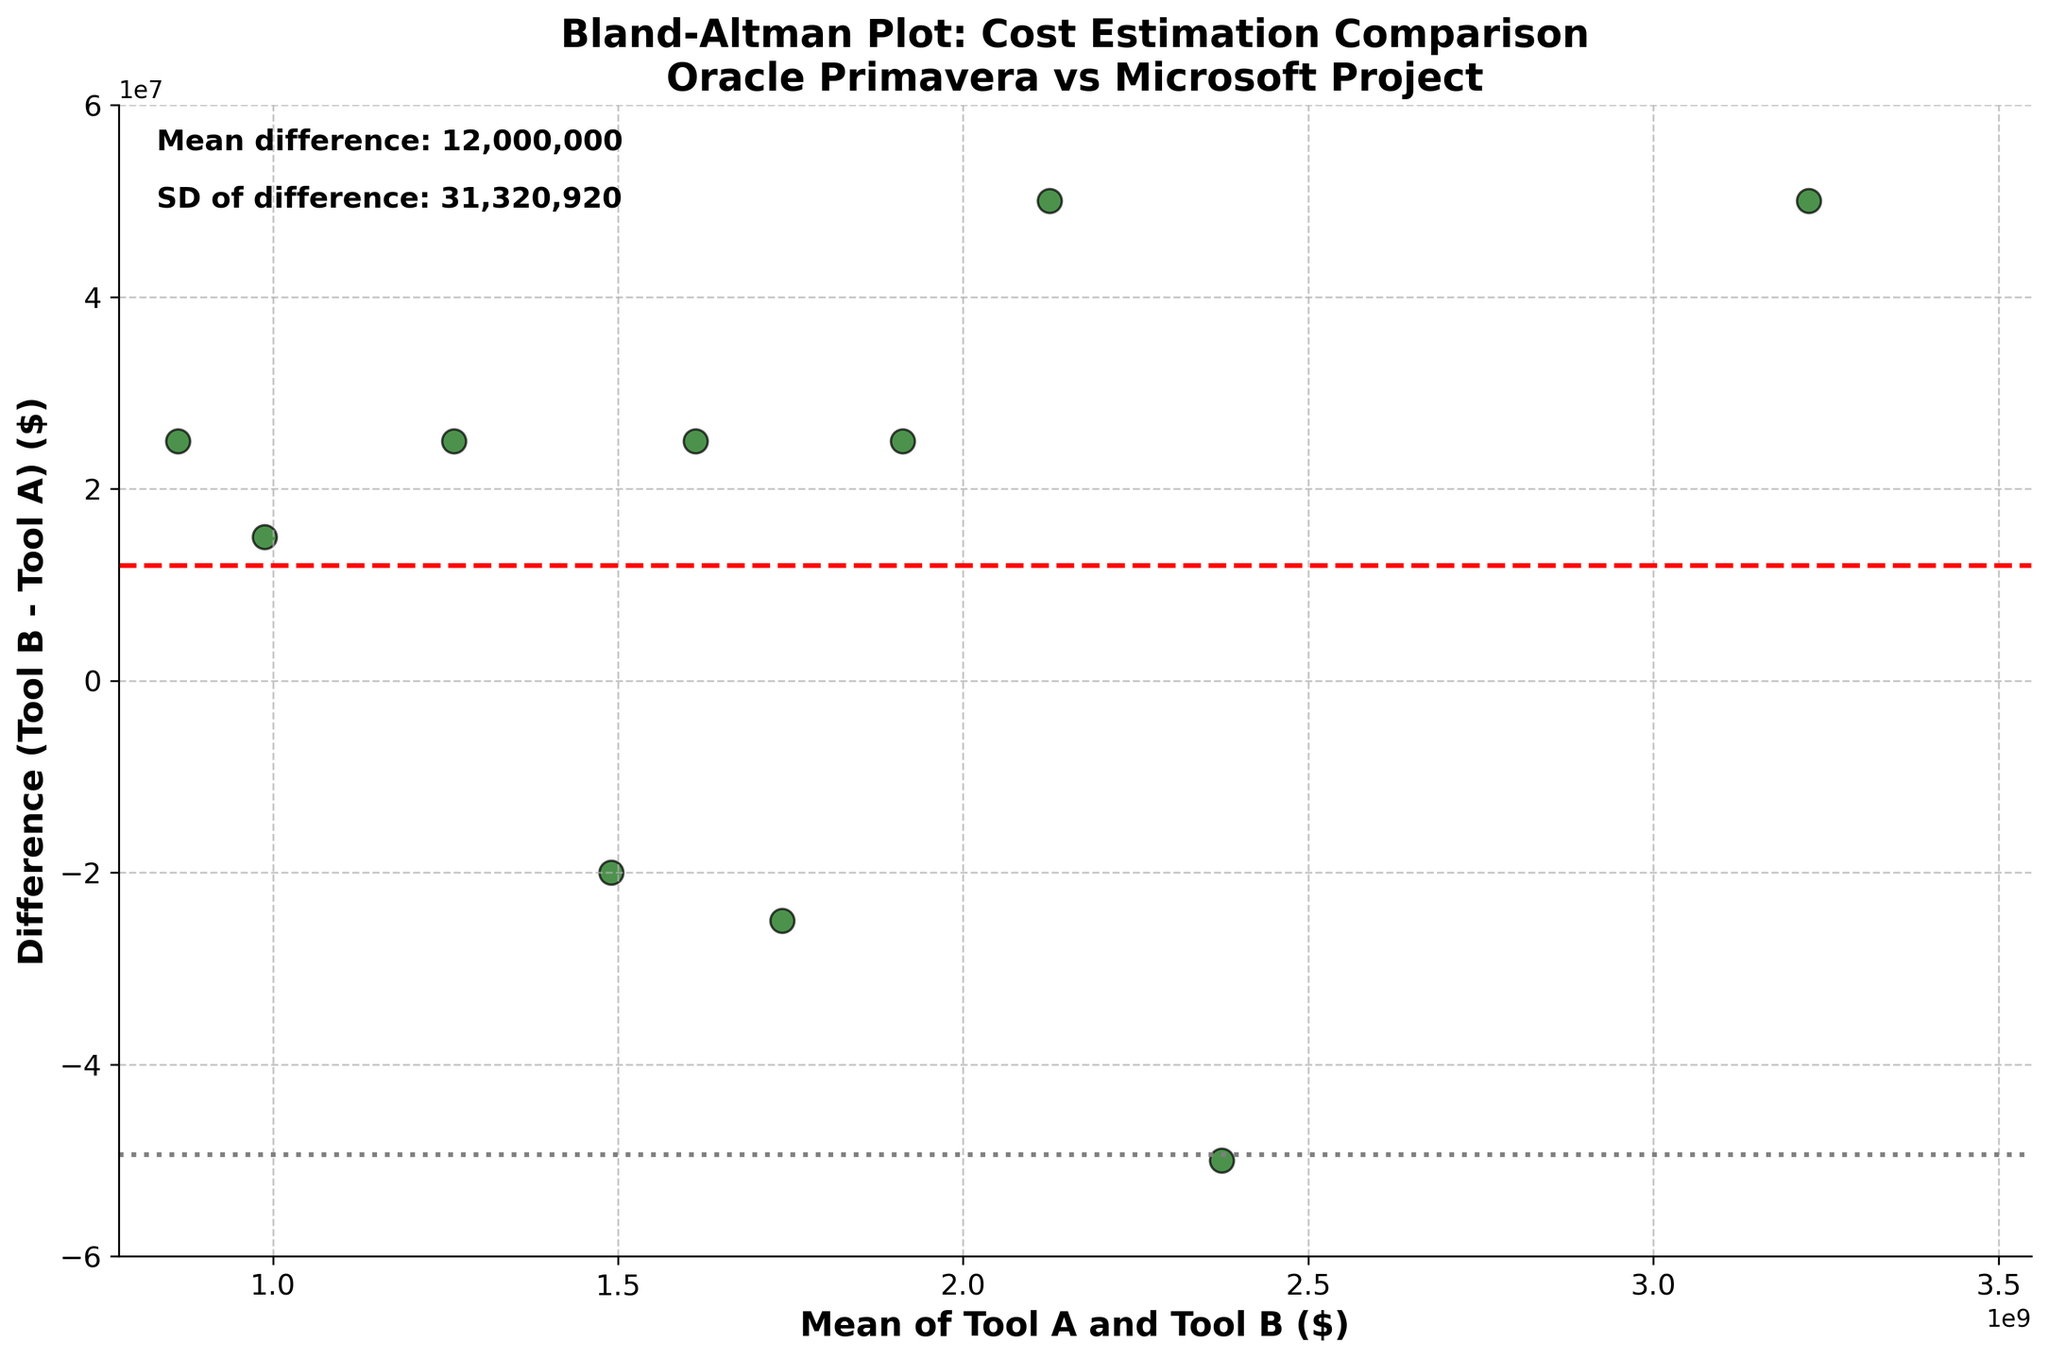What is the title of the figure? The title of the figure is written at the top of the plot.
Answer: Bland-Altman Plot: Cost Estimation Comparison\nOracle Primavera vs Microsoft Project How many data points are represented in the plot? Each data point corresponds to a pair of cost estimates from Tool A and Tool B. Therefore, counting these points gives the total number.
Answer: 10 What is the average difference between the estimates from Tool A and Tool B? The red dashed line represents the mean difference, and the exact value is provided in the text inside the plot.
Answer: 25,000,000 What are the standard deviations of the differences between the two tools' cost estimates? The standard deviation is indicated in the text inside the plot, listed as "SD of difference."
Answer: 16,128,992 What does the horizontal gray dotted line above the mean difference represent? This line represents the mean difference plus 1.96 times the standard deviation of the differences.
Answer: Upper limit of agreement Are most of the differences between the estimates from the two tools within the limits of agreement? The majority of the data points should be within the area bounded by the two gray dotted lines for this to be true.
Answer: Yes What does it mean if a point lies outside the limits of agreement? Points outside the limits of agreement indicate significant discrepancies between the estimates from the two tools for those specific projects.
Answer: Significant discrepancy Which tool generally provides higher cost estimates? If the majority of points are above the mean difference line (red dashed line), Tool B (Microsoft Project) generally provides higher estimates.
Answer: Microsoft Project Is there any apparent trend in the differences concerning the mean of the estimates? If the differences increase or decrease systematically with the mean cost estimates, that indicates a trend.
Answer: No clear trend 